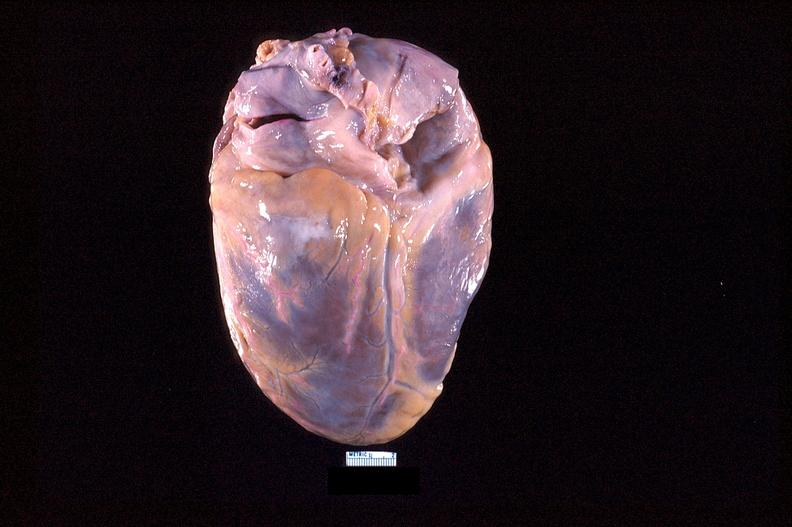does this image show heart, posterior surface, acute posterior myocardial infarction?
Answer the question using a single word or phrase. Yes 